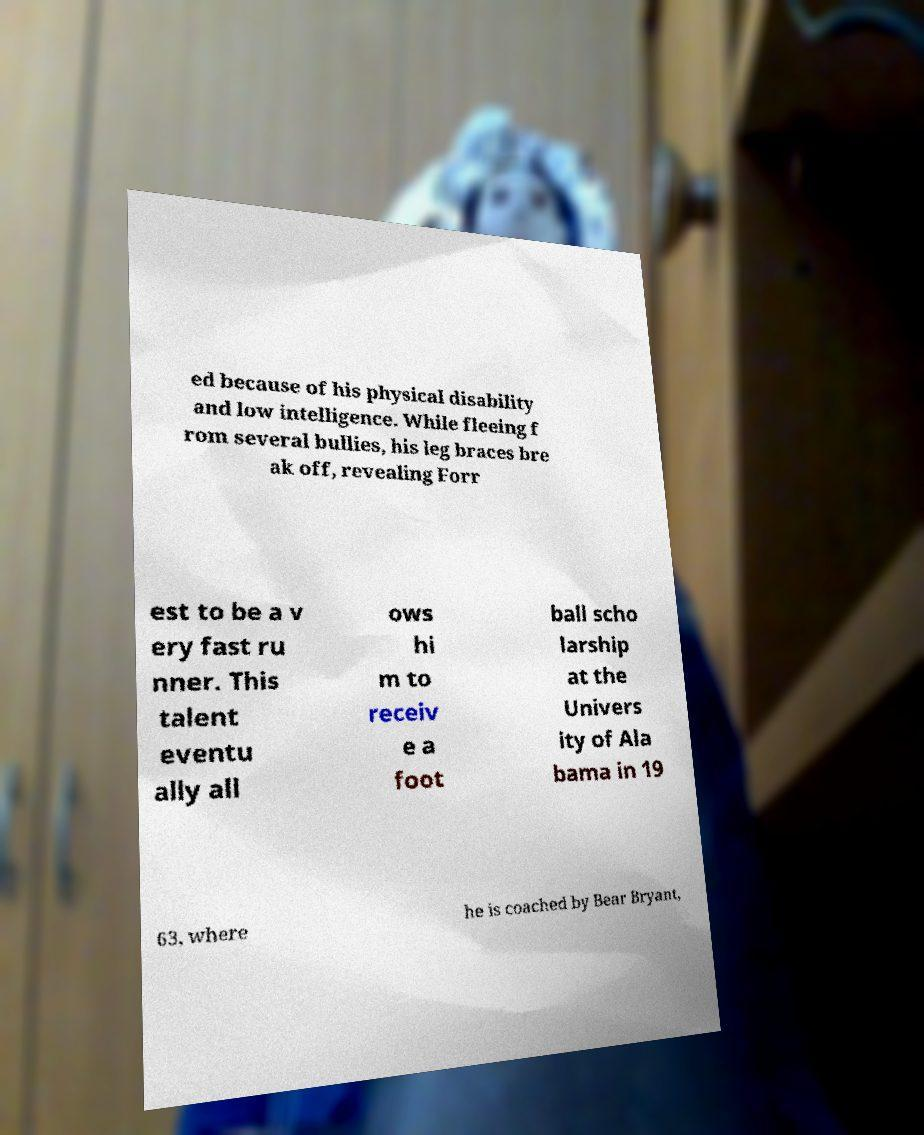There's text embedded in this image that I need extracted. Can you transcribe it verbatim? ed because of his physical disability and low intelligence. While fleeing f rom several bullies, his leg braces bre ak off, revealing Forr est to be a v ery fast ru nner. This talent eventu ally all ows hi m to receiv e a foot ball scho larship at the Univers ity of Ala bama in 19 63, where he is coached by Bear Bryant, 